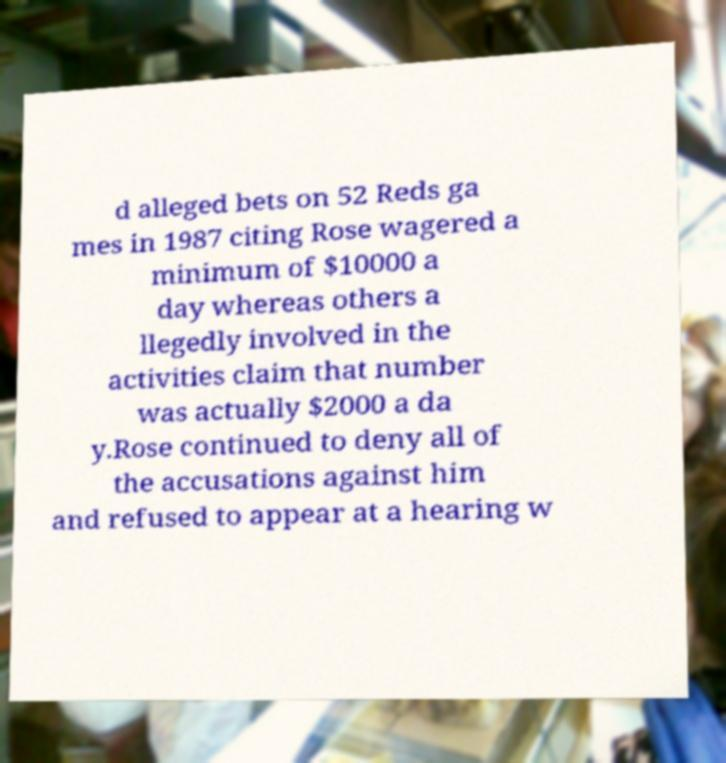I need the written content from this picture converted into text. Can you do that? d alleged bets on 52 Reds ga mes in 1987 citing Rose wagered a minimum of $10000 a day whereas others a llegedly involved in the activities claim that number was actually $2000 a da y.Rose continued to deny all of the accusations against him and refused to appear at a hearing w 